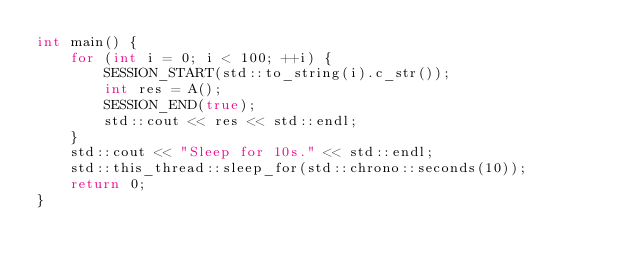Convert code to text. <code><loc_0><loc_0><loc_500><loc_500><_C++_>int main() {
    for (int i = 0; i < 100; ++i) {
        SESSION_START(std::to_string(i).c_str());
        int res = A();
        SESSION_END(true);
        std::cout << res << std::endl;
    }
    std::cout << "Sleep for 10s." << std::endl;
    std::this_thread::sleep_for(std::chrono::seconds(10));
    return 0;
}

</code> 